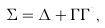Convert formula to latex. <formula><loc_0><loc_0><loc_500><loc_500>\Sigma = \Delta + \Gamma \Gamma ^ { t } ,</formula> 